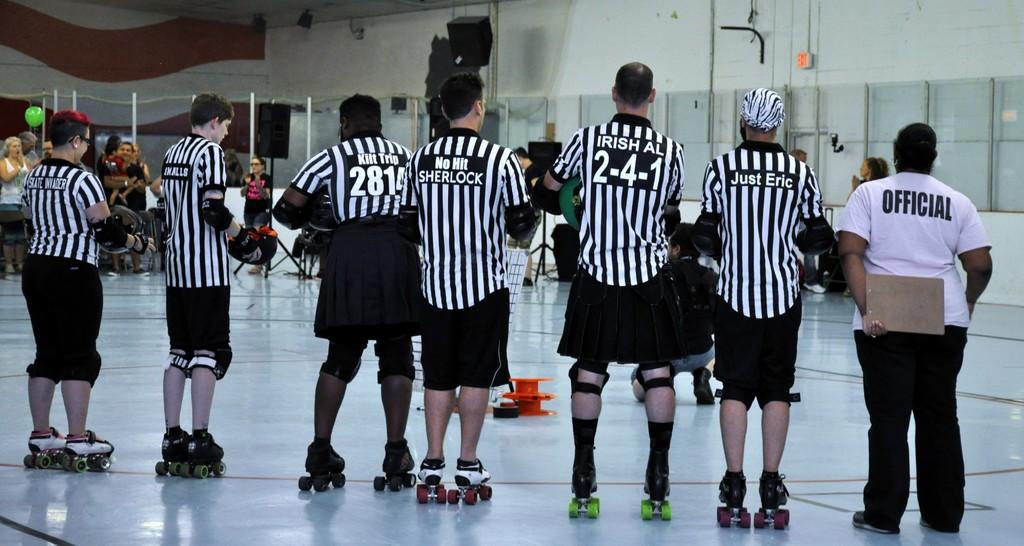Could you give a brief overview of what you see in this image? In this image I can see the group of people with white and black color dresses and these people with the skateboards. In the background I can see the few more people with different color dresses. I can see the balloon, sound boxes and the boards to the wall. 